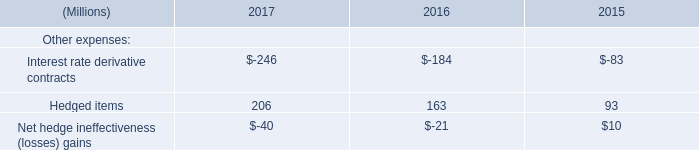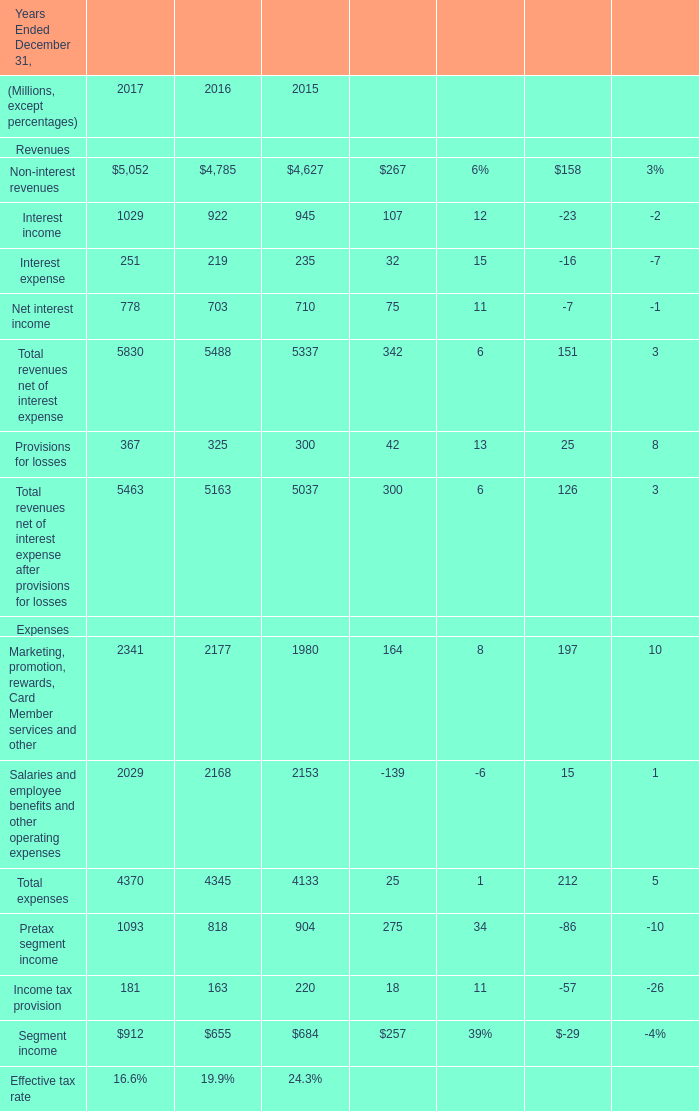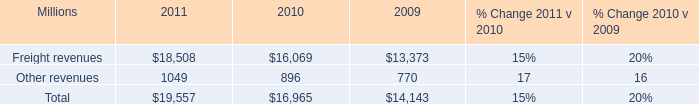What's the total amount of revenues net of interest expense, revenues net of interest expense after provisions for losses, expenses and Pretax segment income in 2017? (in million) 
Computations: (((5830 + 5463) + 4370) + 1093)
Answer: 16756.0. 